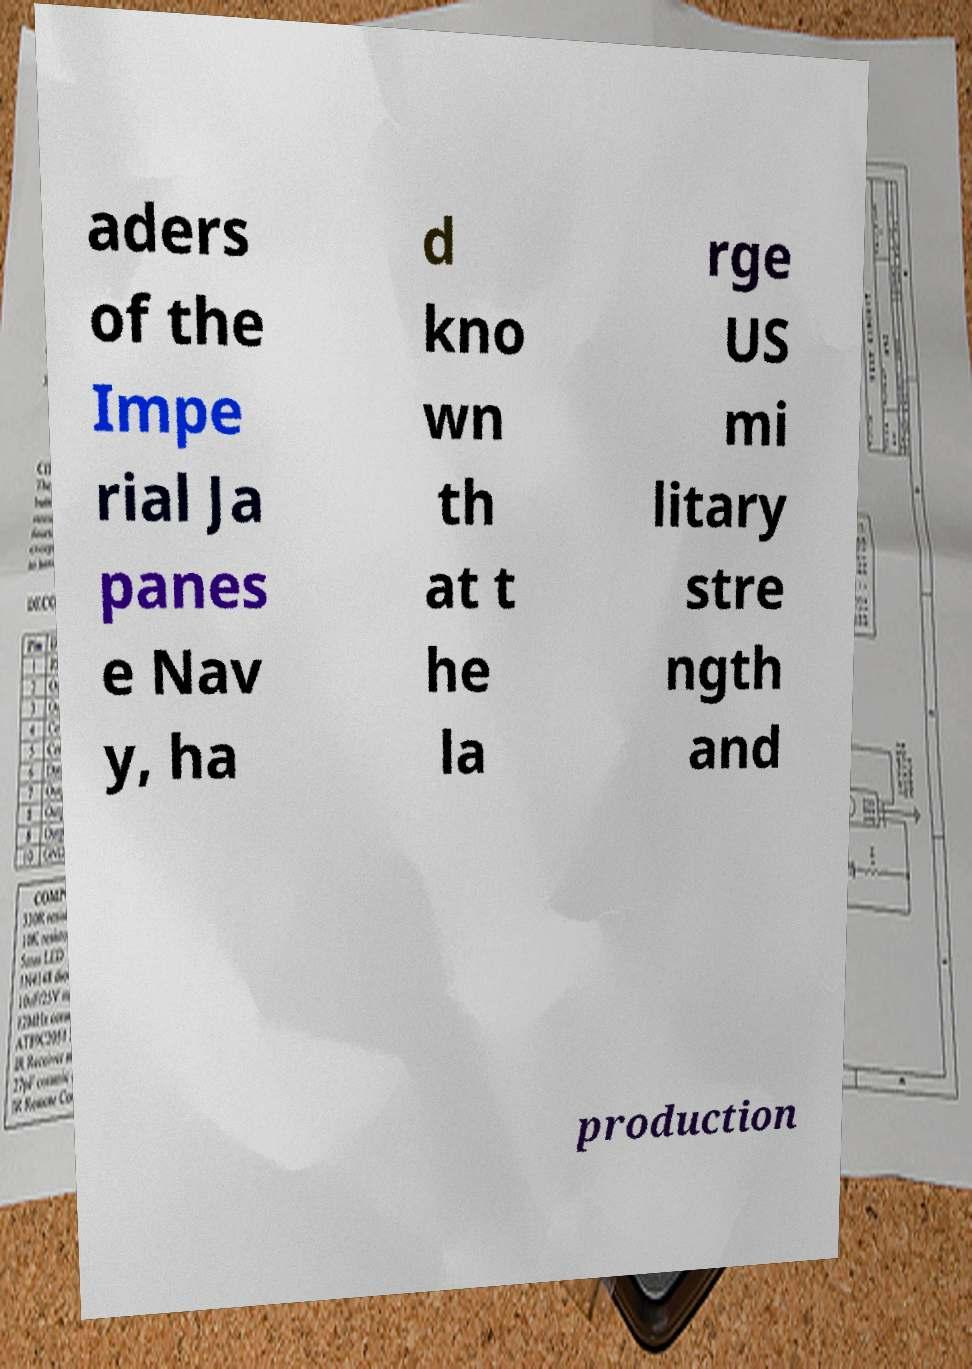For documentation purposes, I need the text within this image transcribed. Could you provide that? aders of the Impe rial Ja panes e Nav y, ha d kno wn th at t he la rge US mi litary stre ngth and production 